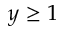Convert formula to latex. <formula><loc_0><loc_0><loc_500><loc_500>y \geq 1</formula> 